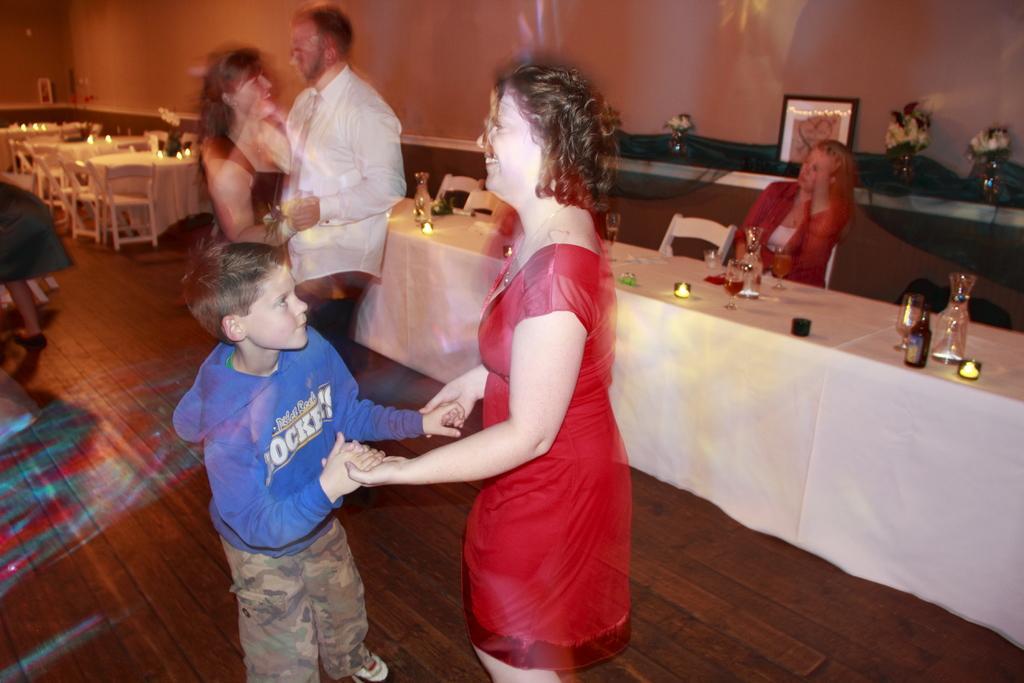Could you give a brief overview of what you see in this image? In this image in the middle there is a woman, she wears a dress, in front of her there is a boy, he wears a jacket, trouser. At the top there is a man, he wears a shirt, trouser, in front of him there is a woman, she wears a dress. On the right there is a woman, she wears a suit, she is sitting. In the middle there is a table on that there are bottles, glasses and lights. In the background there are tables, chairs, people, photo frames, flower vases, lights and a wall. 